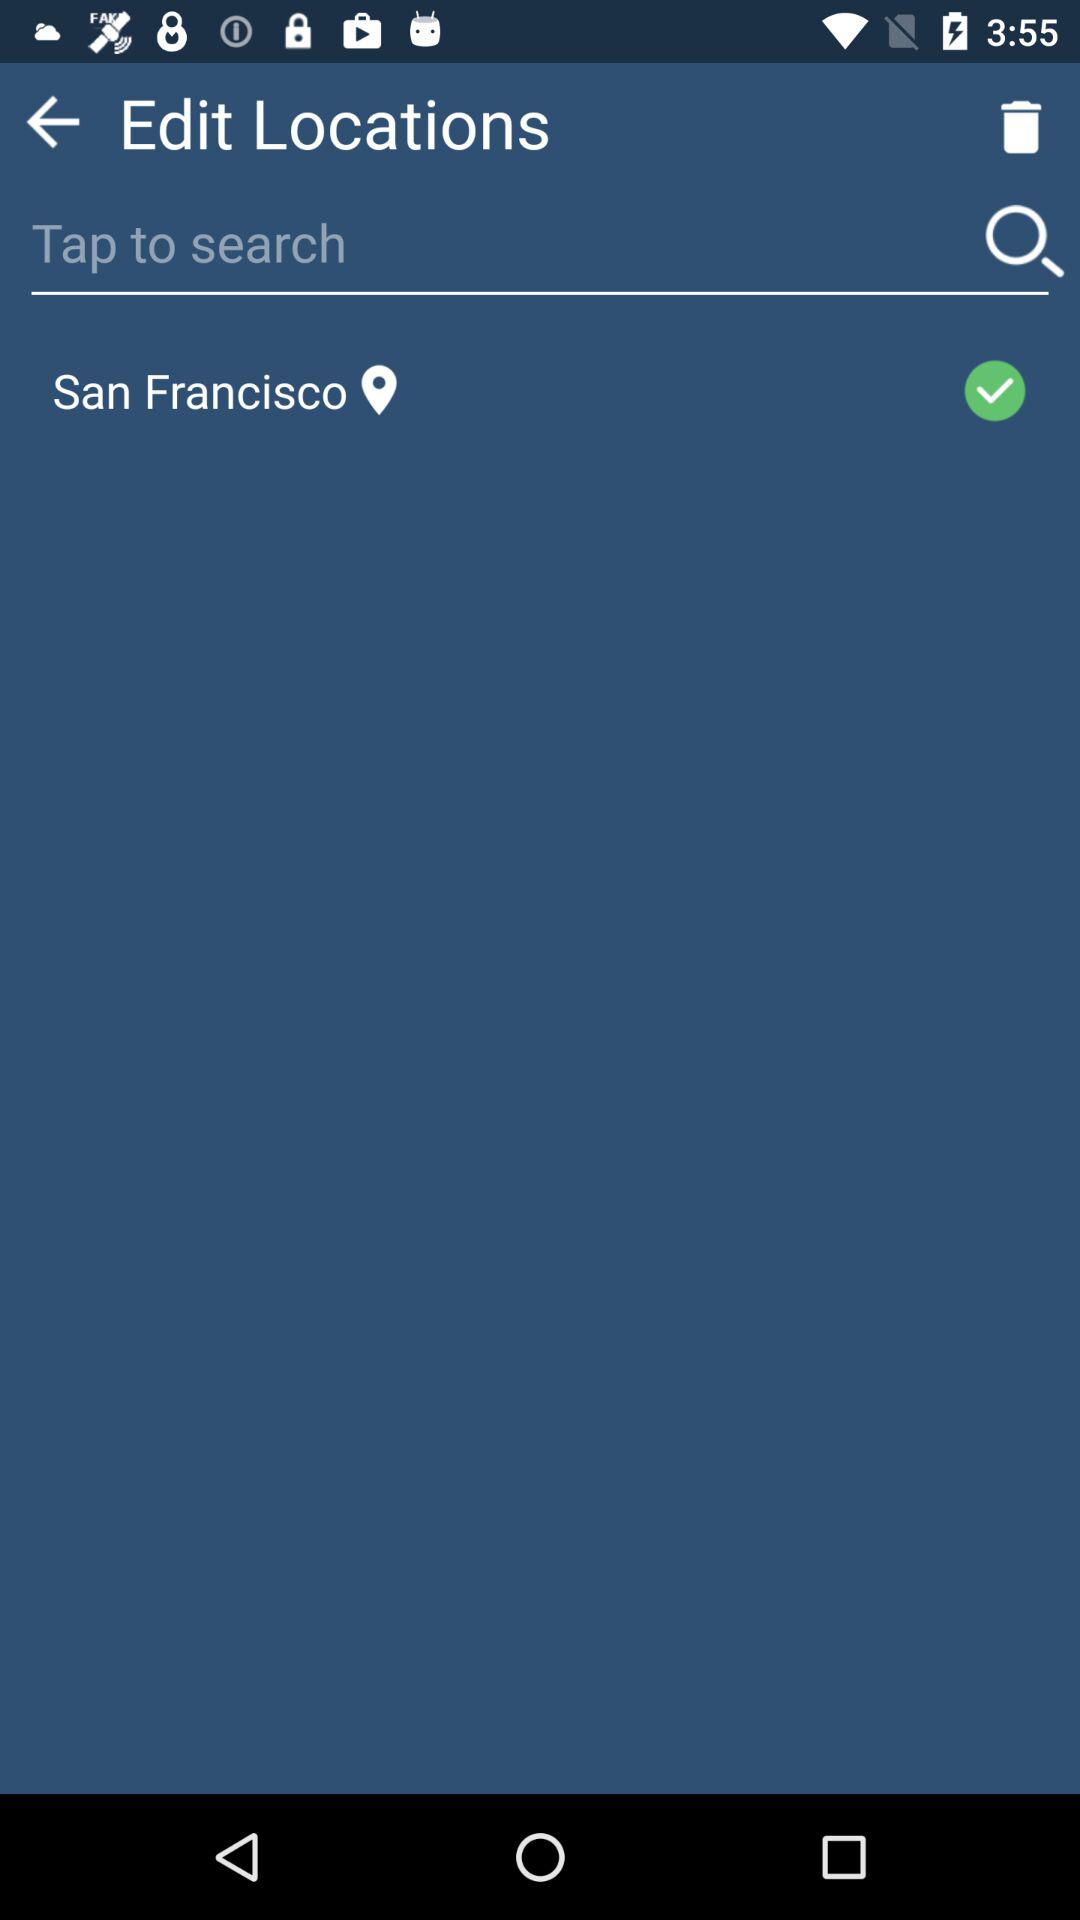How many more locations are there than checkboxes?
Answer the question using a single word or phrase. 1 